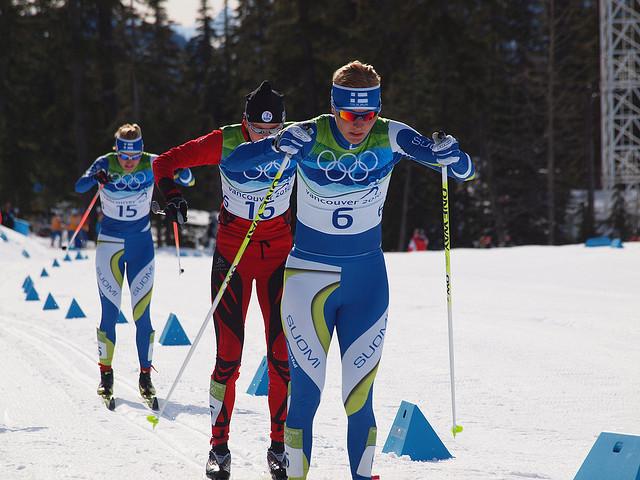How many red skiers do you see?
Give a very brief answer. 1. How is the skier in the middle dressed differently?
Be succinct. Red. What is the number on the shirt of the person in the lead?
Be succinct. 6. What number is this cross country skier?
Keep it brief. 6. Does this look like a competition?
Be succinct. Yes. How many people with blue shirts?
Be succinct. 2. What are the people in the picture doing?
Be succinct. Skiing. 